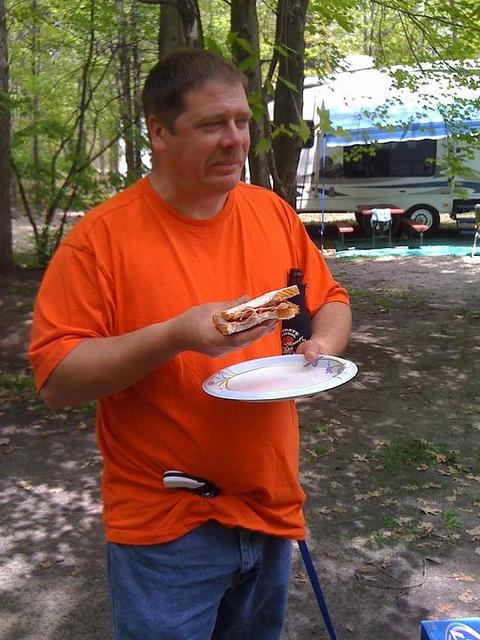What is he eating?
Keep it brief. Sandwich. Does he have a gun?
Give a very brief answer. Yes. Is there a grill?
Keep it brief. No. What color is the man's shirt?
Keep it brief. Orange. 